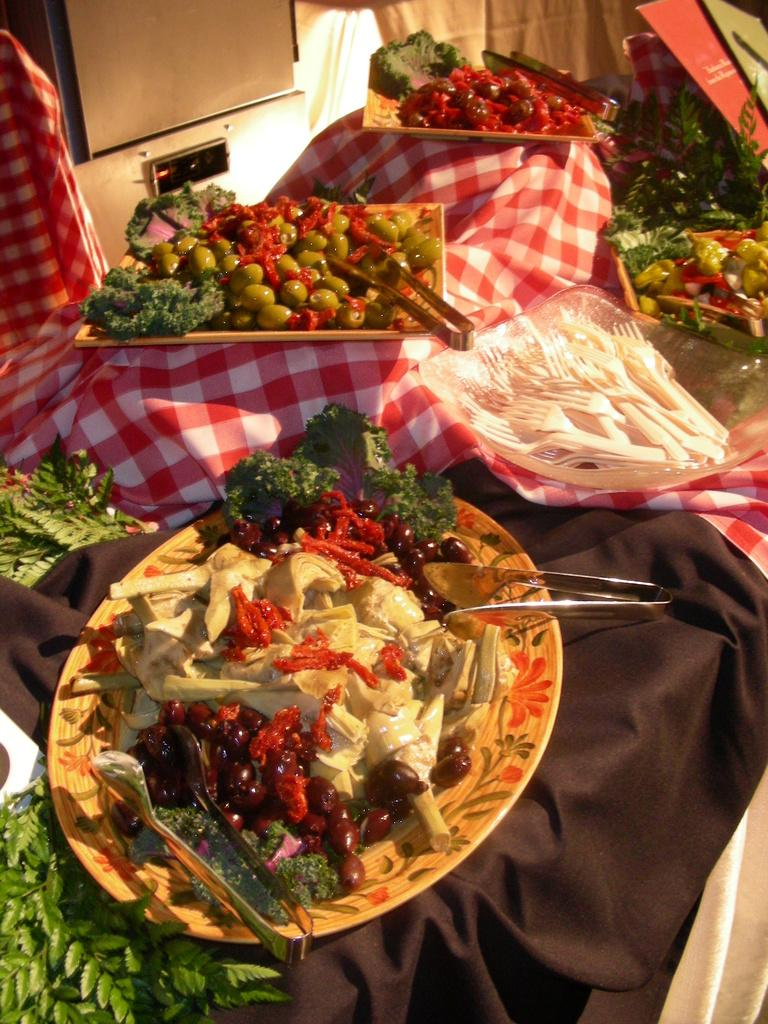What types of food are on the plates in the image? There are vegetables and fruits on plates in the image. How are the plates arranged in the image? The plates are arranged on a table. What type of material covers the table in the image? There are cloths on the table. What can be seen in the background of the image? There is a light in the background of the image. Where is the alley located in the image? There is no alley present in the image. What type of glue is used to hold the fruits and vegetables together in the image? There is no glue used to hold the fruits and vegetables together in the image; they are simply arranged on plates. 